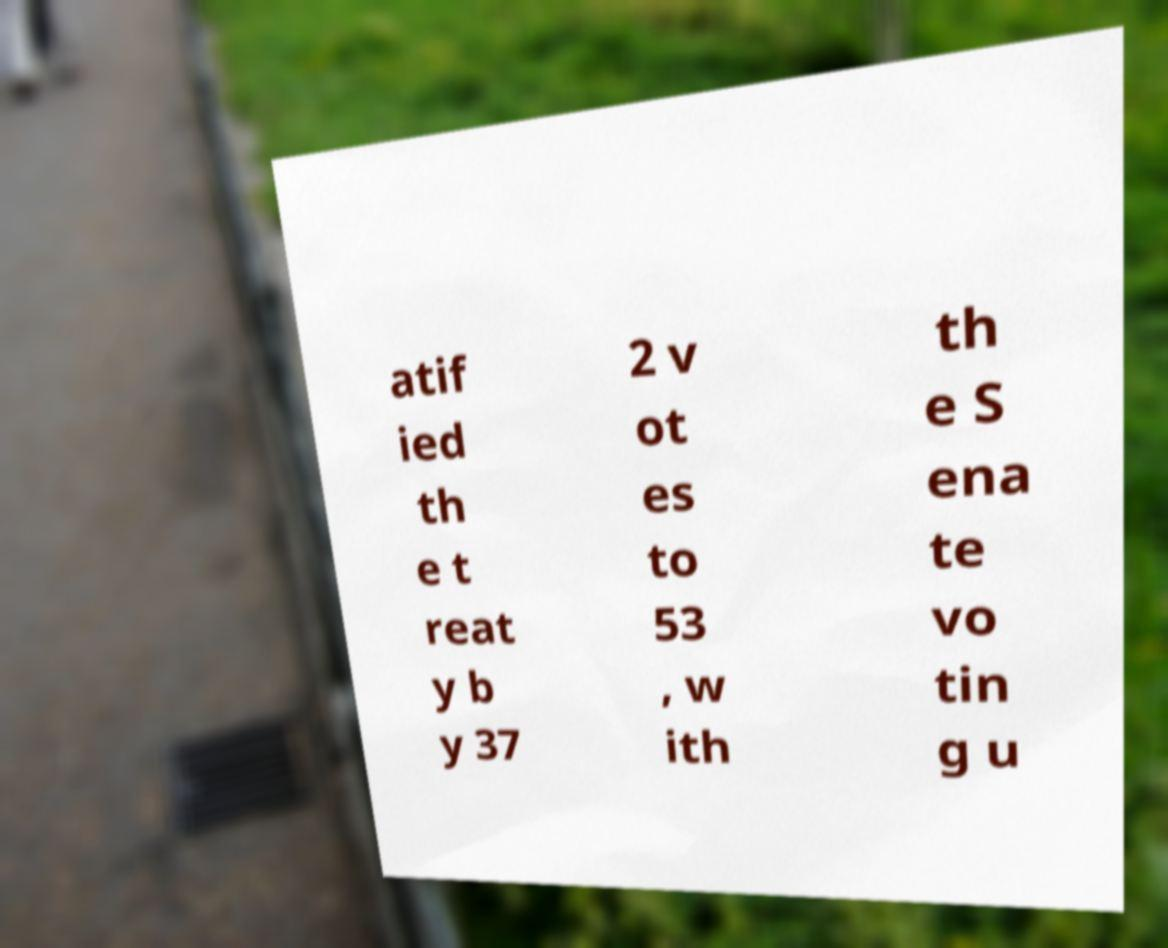Could you assist in decoding the text presented in this image and type it out clearly? atif ied th e t reat y b y 37 2 v ot es to 53 , w ith th e S ena te vo tin g u 